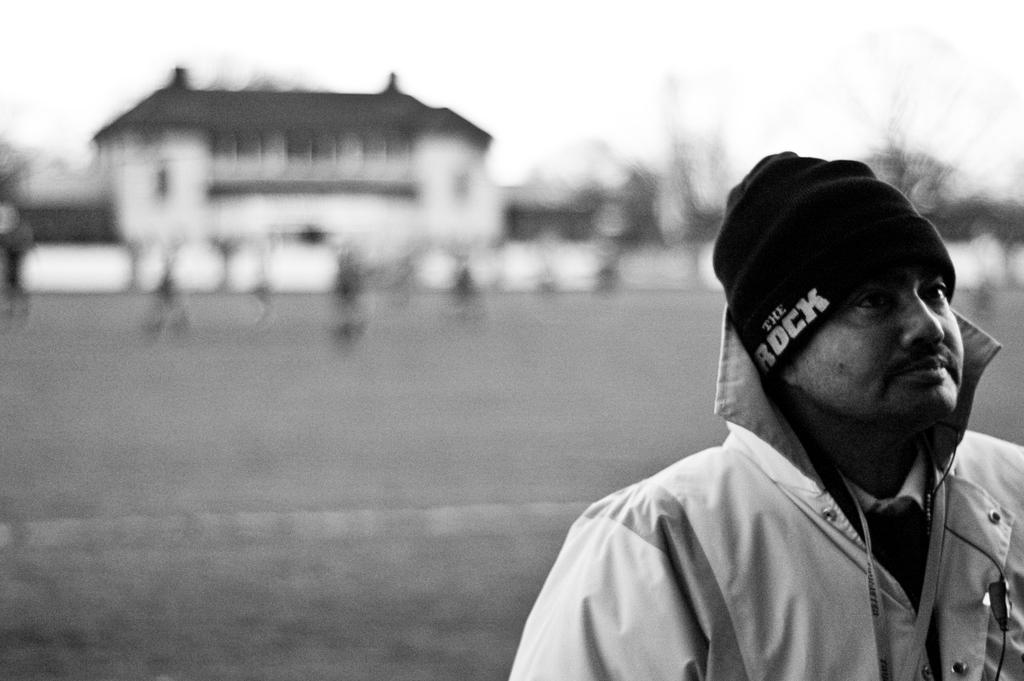What is the main subject of the image? There is a person standing in the image. Can you describe the background of the image? The background of the image is blurry. How many kittens are playing with the letters in the band in the image? There are no kittens, letters, or bands present in the image. 